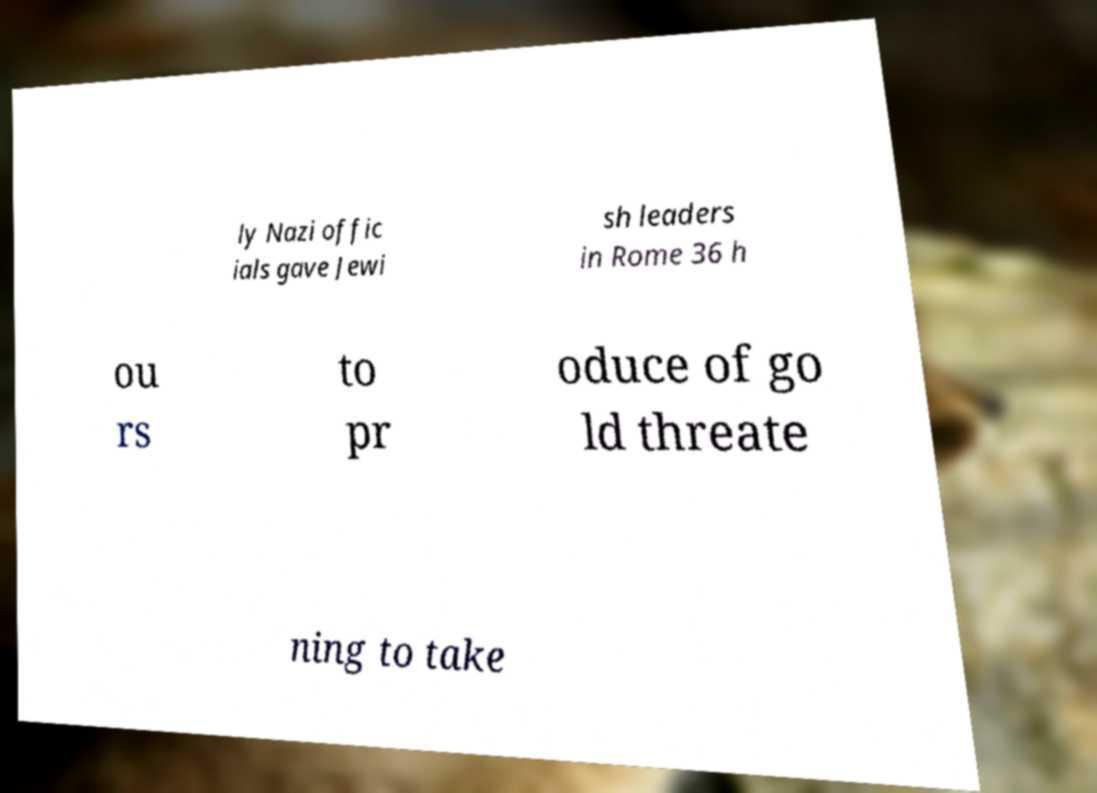Could you extract and type out the text from this image? ly Nazi offic ials gave Jewi sh leaders in Rome 36 h ou rs to pr oduce of go ld threate ning to take 